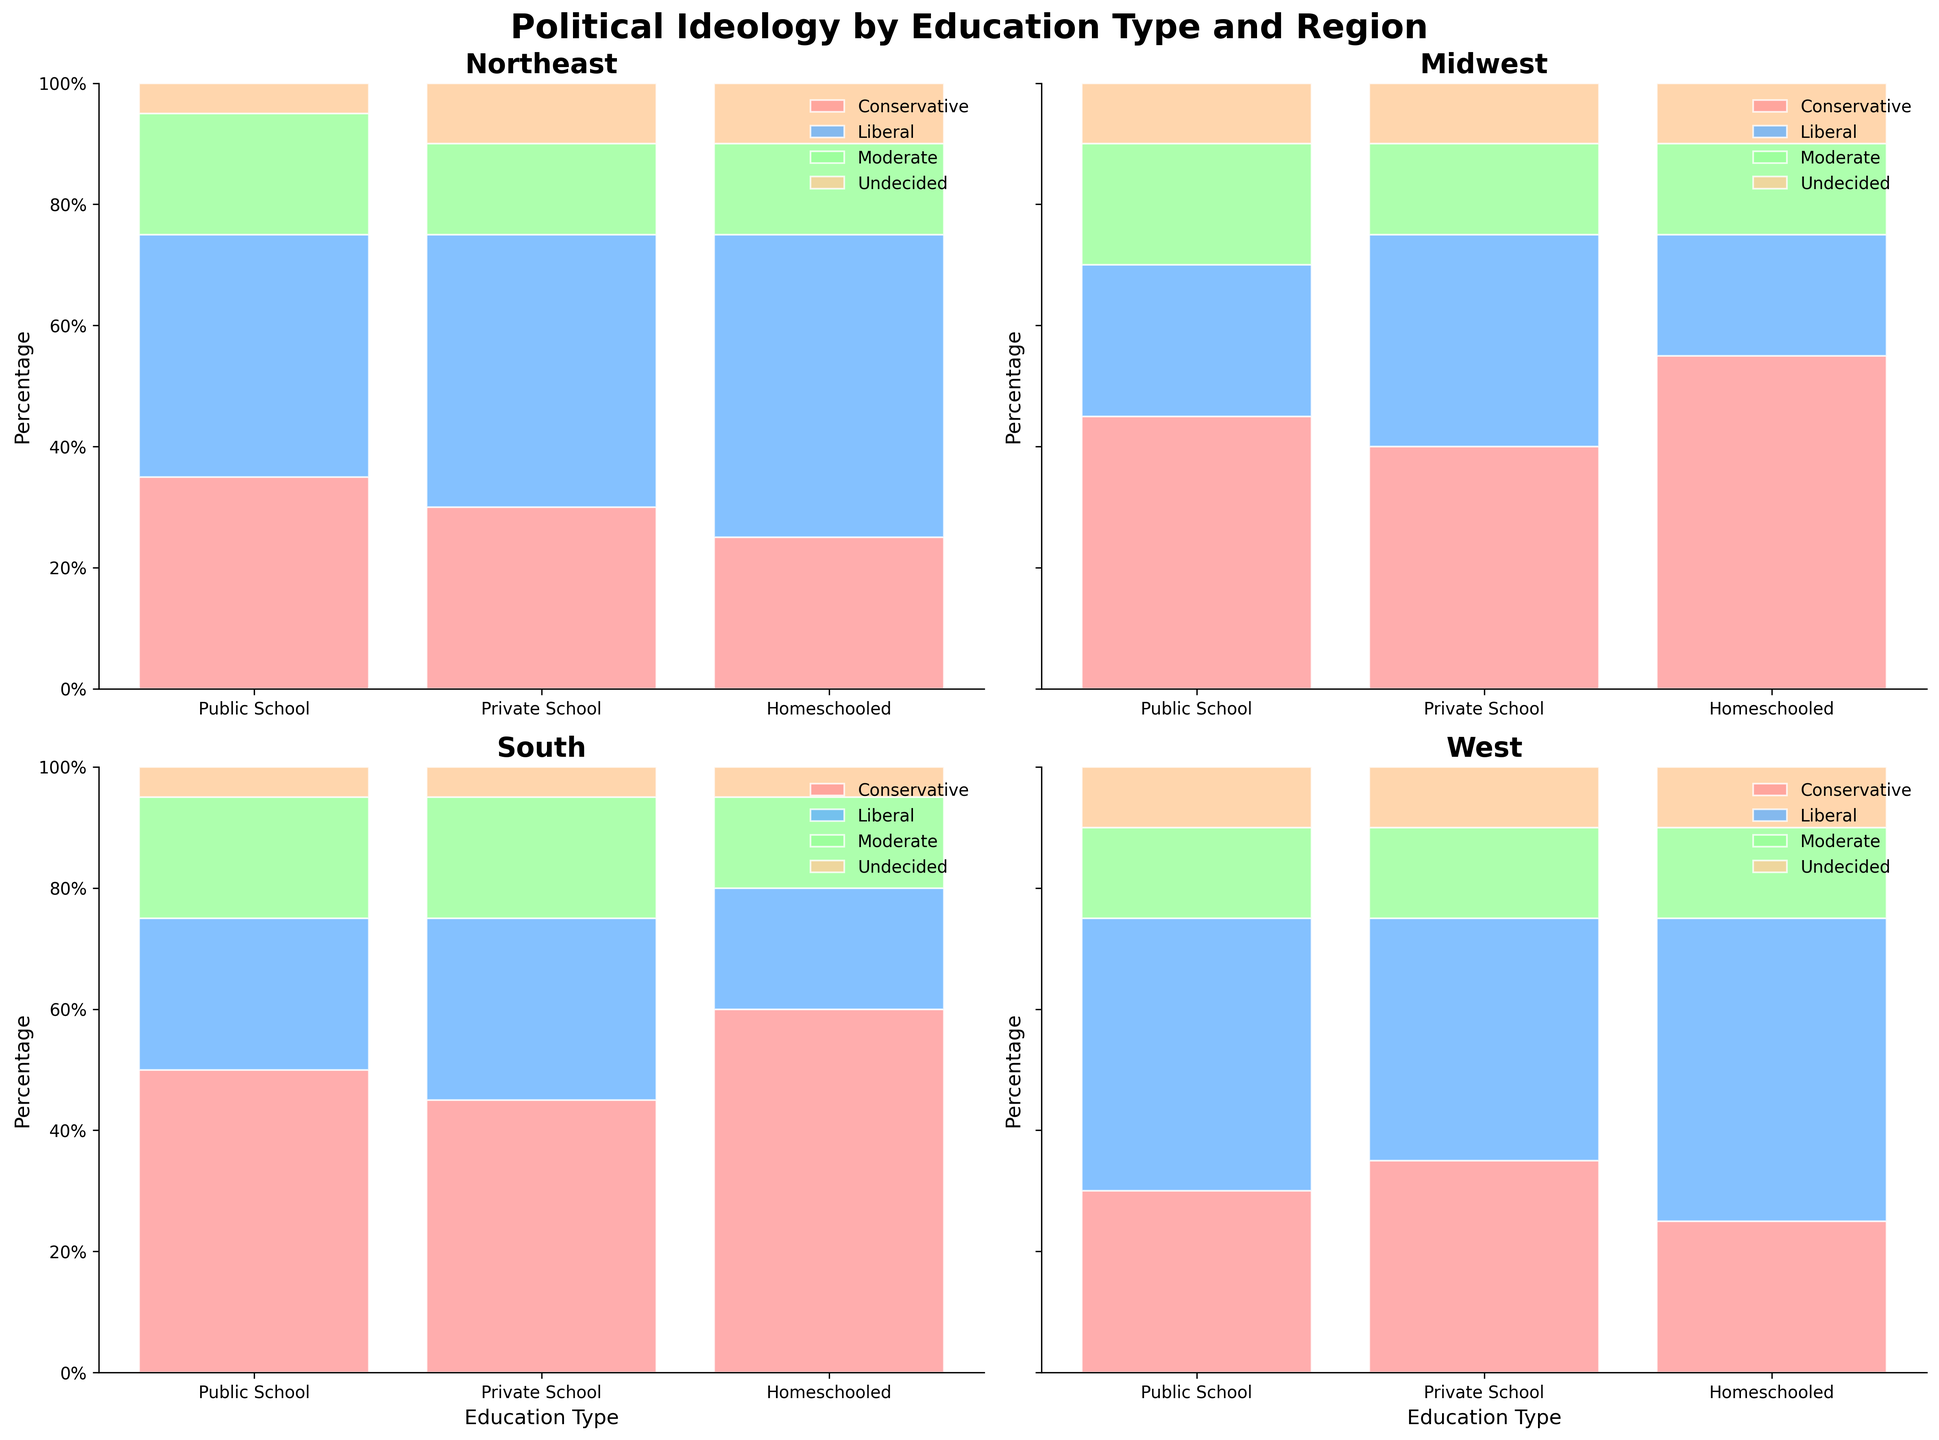what is the title of the figure? The title of the figure is typically positioned at the top and is meant to give a clear indication of what the figure represents.
Answer: Political Ideology by Education Type and Region Which education type has the highest percentage of liberals in the Northeast? Look at the Northeast section of the chart, identify the highest segment of the bar labeled "Liberal" among the different education types.
Answer: Homeschooled What is the percentage of conservatives among privately-schooled individuals in the Midwest? In the Midwest section, refer to the portion of the Private School bar labeled "Conservative".
Answer: 40% Compare the percentage of moderates in public schools between the Northeast and the South. Which region has a higher percentage? Locate and compare the "Moderate" sections of the Public School bars in both the Northeast and the South panels.
Answer: Northeast What is the combined percentage of undecided individuals in private schools across all regions? Add the percentages of the "Undecided" sections for Private Schools in each region: Northeast, Midwest, South, and West.
Answer: 35% Which region has the widest spread of political ideologies among homeschooled individuals? Compare the spread (range) of each political ideology category (Conservative, Liberal, Moderate, Undecided) for homeschooled individuals in each region by looking at the heights of the segments.
Answer: South How does the percentage of conservatives in public schools in the West compare to those in the Northeast? Check the height of the "Conservative" section in Public Schools for both the West and the Northeast regions.
Answer: Less in the West Identify the education type and region with the lowest percentage of undecided individuals. Among all the segments labeled "Undecided" across different education types and regions, identify the smallest one.
Answer: South Public School What can you infer about the political ideology of homeschooled individuals in the West? Examine all segments of the bar for homeschooled individuals in the West. Since it's a 100% stacked area chart, observe the height of each ideology segment to understand the distribution.
Answer: Mostly Liberal What education type in the South has the smallest percentage of liberals? Look at the "Liberal" section within the South panel and identify the smallest section among public, private, and homeschooled bars.
Answer: Homeschooled 